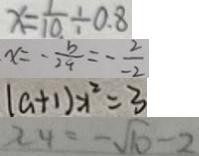Convert formula to latex. <formula><loc_0><loc_0><loc_500><loc_500>x = \frac { 1 } { 1 0 } \div 0 . 8 
 x = - \frac { b } { 2 a } = - \frac { 2 } { - 2 } 
 ( a + 1 ) x ^ { 2 } = 3 
 x _ { 4 } = - \sqrt { 1 0 } - 2</formula> 